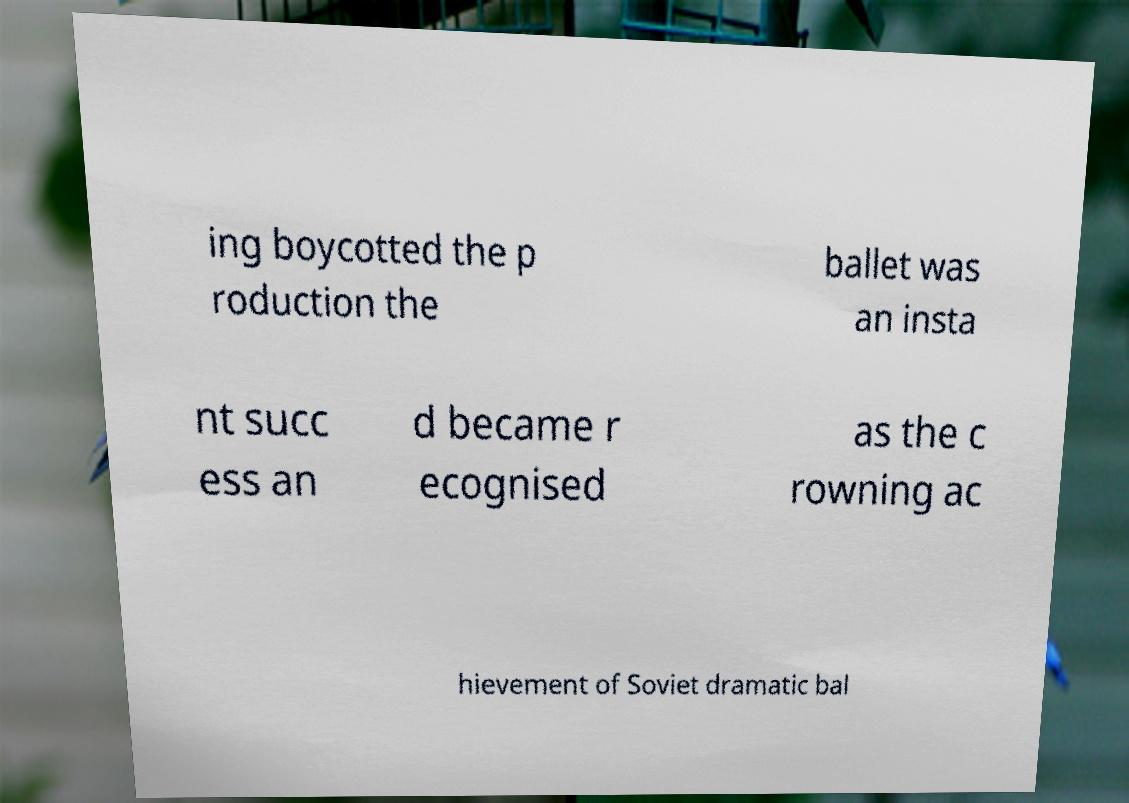There's text embedded in this image that I need extracted. Can you transcribe it verbatim? ing boycotted the p roduction the ballet was an insta nt succ ess an d became r ecognised as the c rowning ac hievement of Soviet dramatic bal 